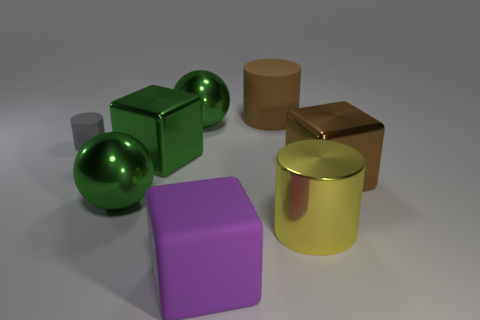There is a small gray rubber cylinder; what number of brown things are on the left side of it?
Your answer should be very brief. 0. There is a big cube to the right of the cylinder that is in front of the big ball that is in front of the tiny gray matte cylinder; what is its color?
Your response must be concise. Brown. There is a large rubber thing that is behind the purple rubber block; is its color the same as the metallic cube that is on the right side of the big purple rubber cube?
Ensure brevity in your answer.  Yes. There is a large brown metallic object in front of the green metallic cube in front of the gray matte cylinder; what shape is it?
Keep it short and to the point. Cube. Are there any balls of the same size as the matte cube?
Provide a succinct answer. Yes. How many brown rubber objects have the same shape as the big yellow object?
Your answer should be compact. 1. Is the number of brown shiny things left of the large brown block the same as the number of purple matte objects behind the purple rubber block?
Your response must be concise. Yes. Are any large brown cubes visible?
Offer a terse response. Yes. There is a block that is on the right side of the matte object in front of the large cylinder in front of the tiny matte thing; what is its size?
Make the answer very short. Large. What shape is the purple matte object that is the same size as the brown shiny cube?
Ensure brevity in your answer.  Cube. 